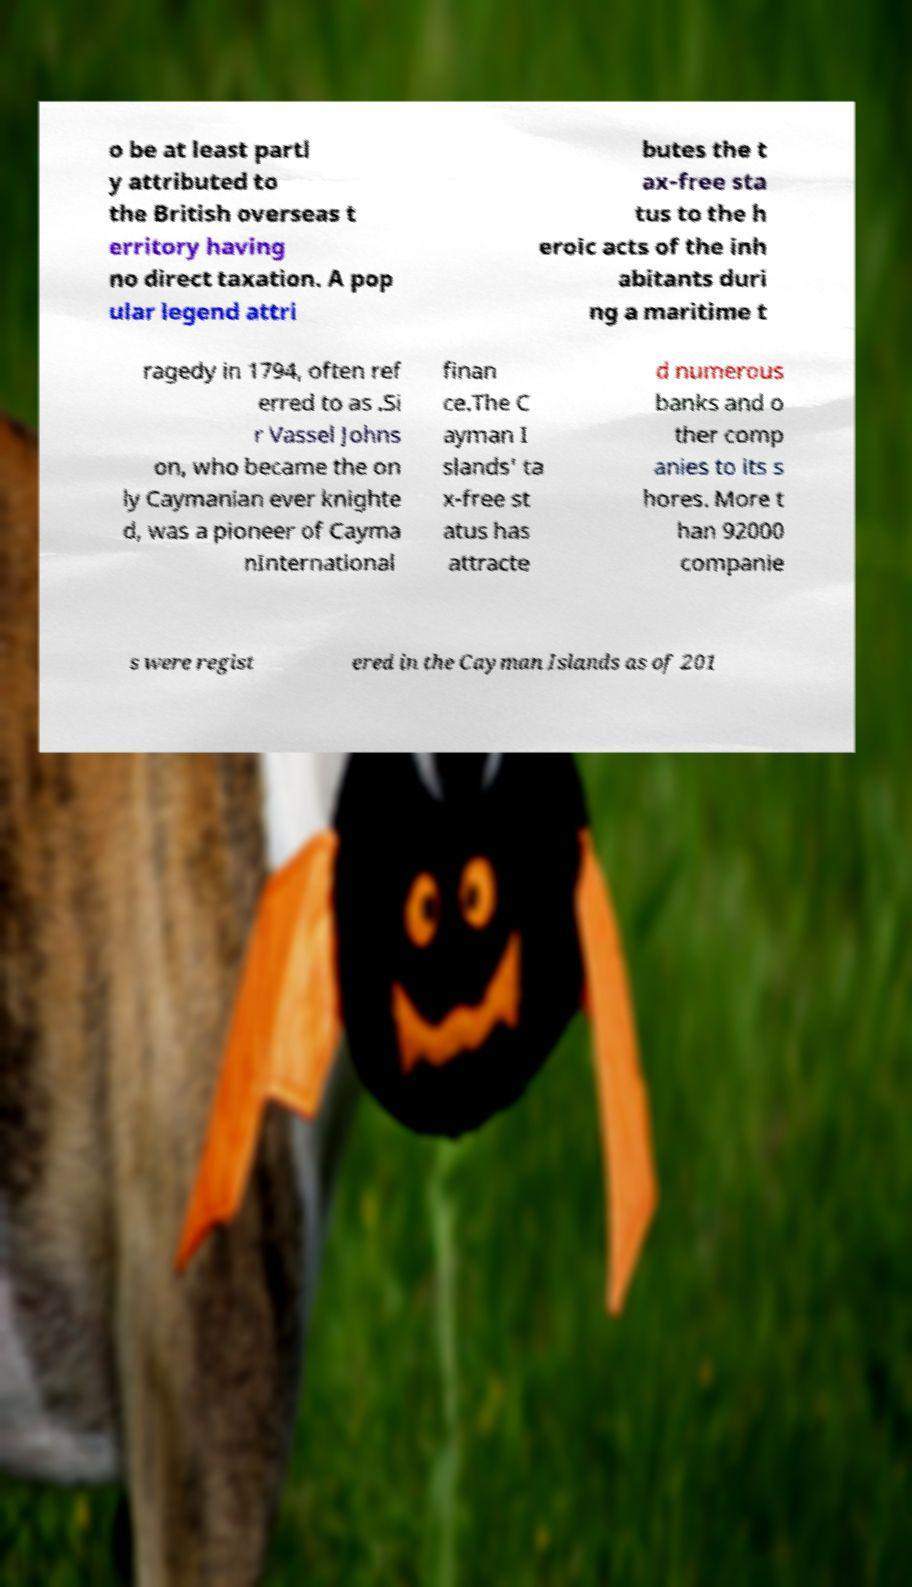Can you read and provide the text displayed in the image?This photo seems to have some interesting text. Can you extract and type it out for me? o be at least partl y attributed to the British overseas t erritory having no direct taxation. A pop ular legend attri butes the t ax-free sta tus to the h eroic acts of the inh abitants duri ng a maritime t ragedy in 1794, often ref erred to as .Si r Vassel Johns on, who became the on ly Caymanian ever knighte d, was a pioneer of Cayma nInternational finan ce.The C ayman I slands' ta x-free st atus has attracte d numerous banks and o ther comp anies to its s hores. More t han 92000 companie s were regist ered in the Cayman Islands as of 201 